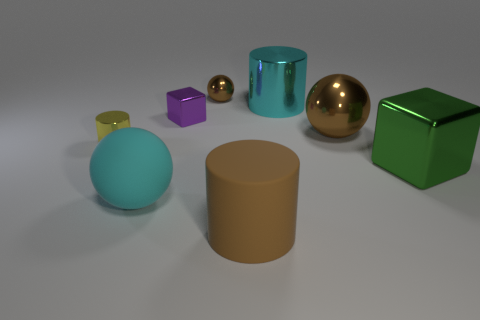Subtract all yellow cubes. How many brown balls are left? 2 Subtract all brown balls. How many balls are left? 1 Add 1 brown shiny objects. How many objects exist? 9 Subtract all cubes. How many objects are left? 6 Add 8 large cyan spheres. How many large cyan spheres exist? 9 Subtract 1 brown spheres. How many objects are left? 7 Subtract all yellow metallic cylinders. Subtract all big rubber cylinders. How many objects are left? 6 Add 4 brown metal spheres. How many brown metal spheres are left? 6 